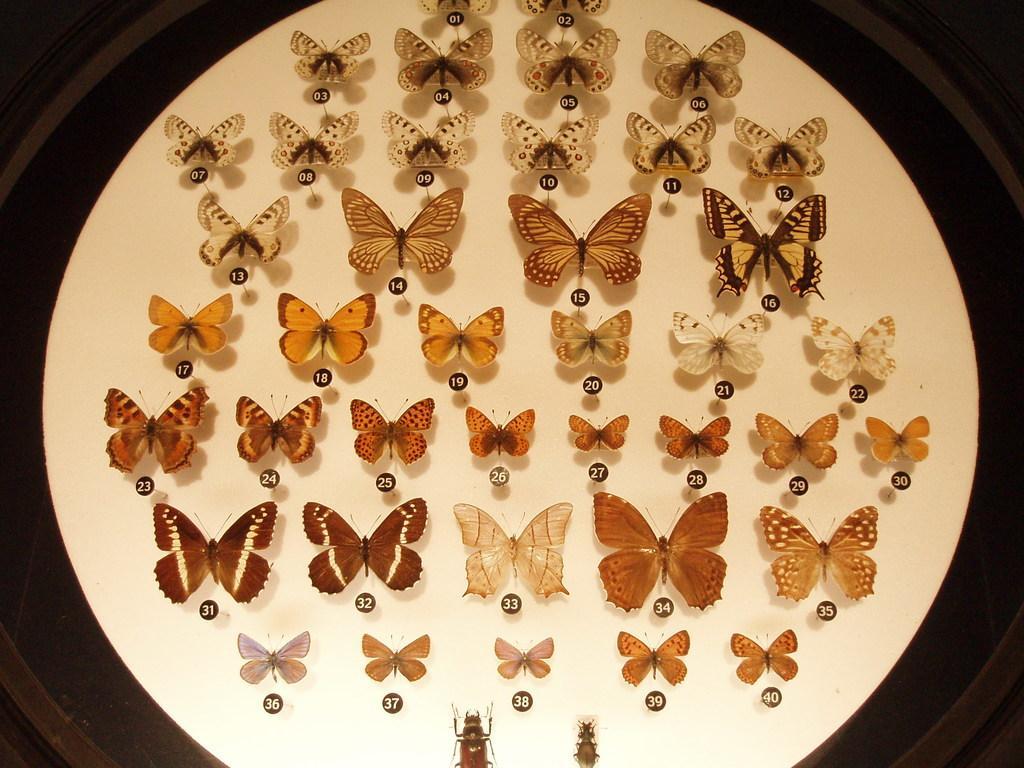Can you describe this image briefly? There is a white surface, on the surface there are different butterflies and insects. 